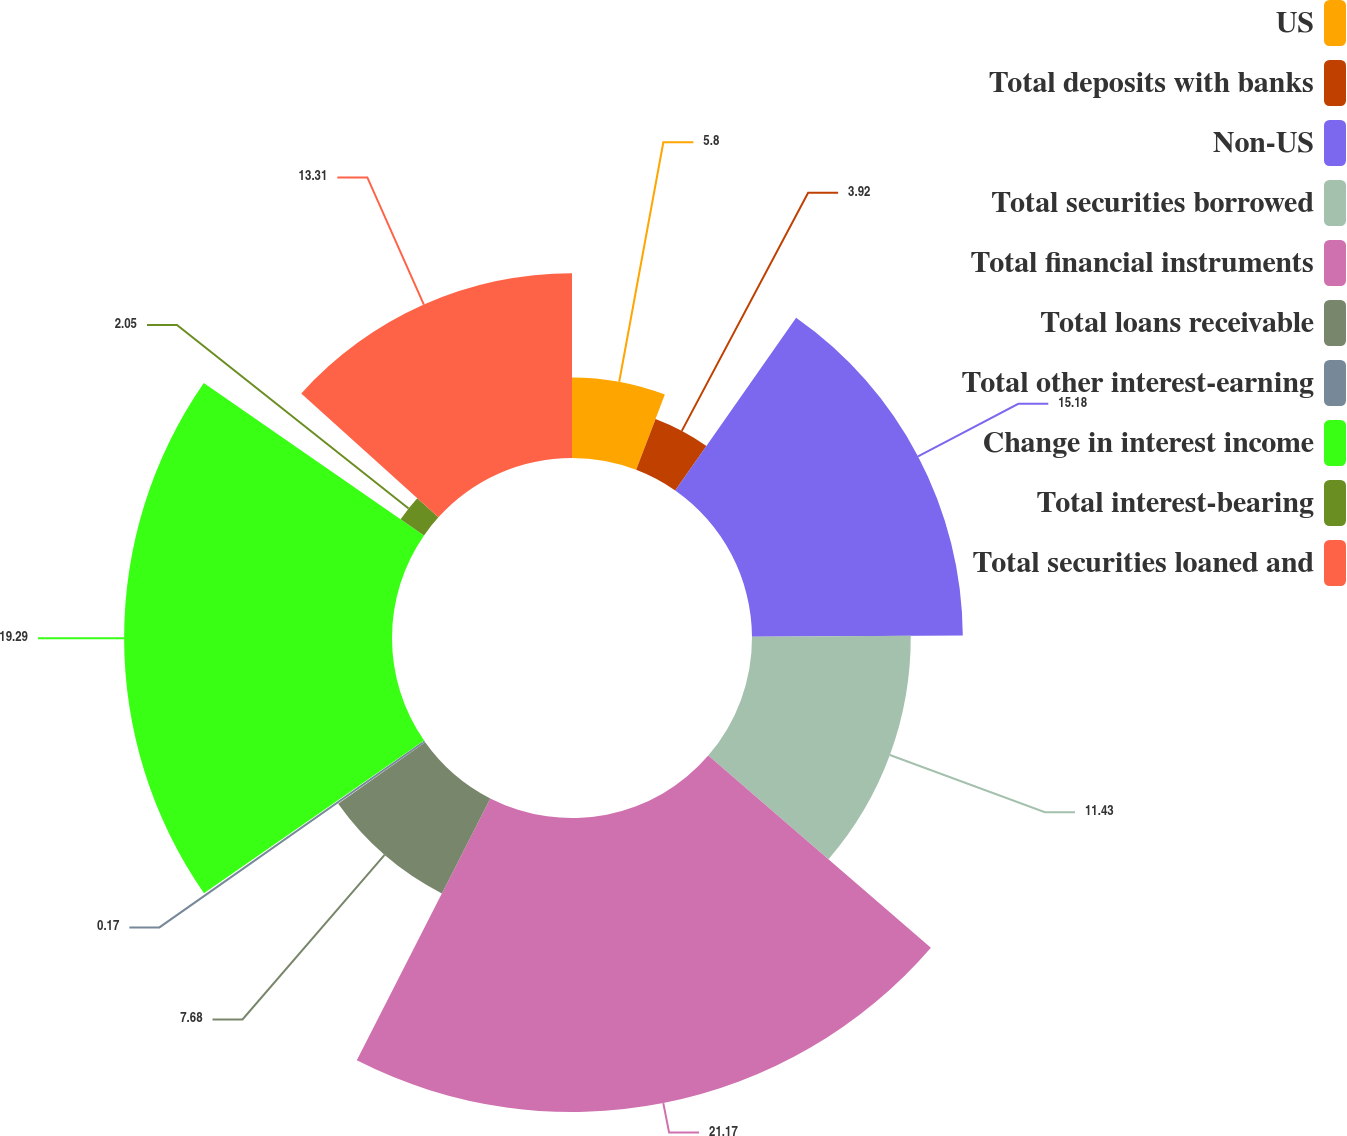Convert chart. <chart><loc_0><loc_0><loc_500><loc_500><pie_chart><fcel>US<fcel>Total deposits with banks<fcel>Non-US<fcel>Total securities borrowed<fcel>Total financial instruments<fcel>Total loans receivable<fcel>Total other interest-earning<fcel>Change in interest income<fcel>Total interest-bearing<fcel>Total securities loaned and<nl><fcel>5.8%<fcel>3.92%<fcel>15.18%<fcel>11.43%<fcel>21.17%<fcel>7.68%<fcel>0.17%<fcel>19.29%<fcel>2.05%<fcel>13.31%<nl></chart> 